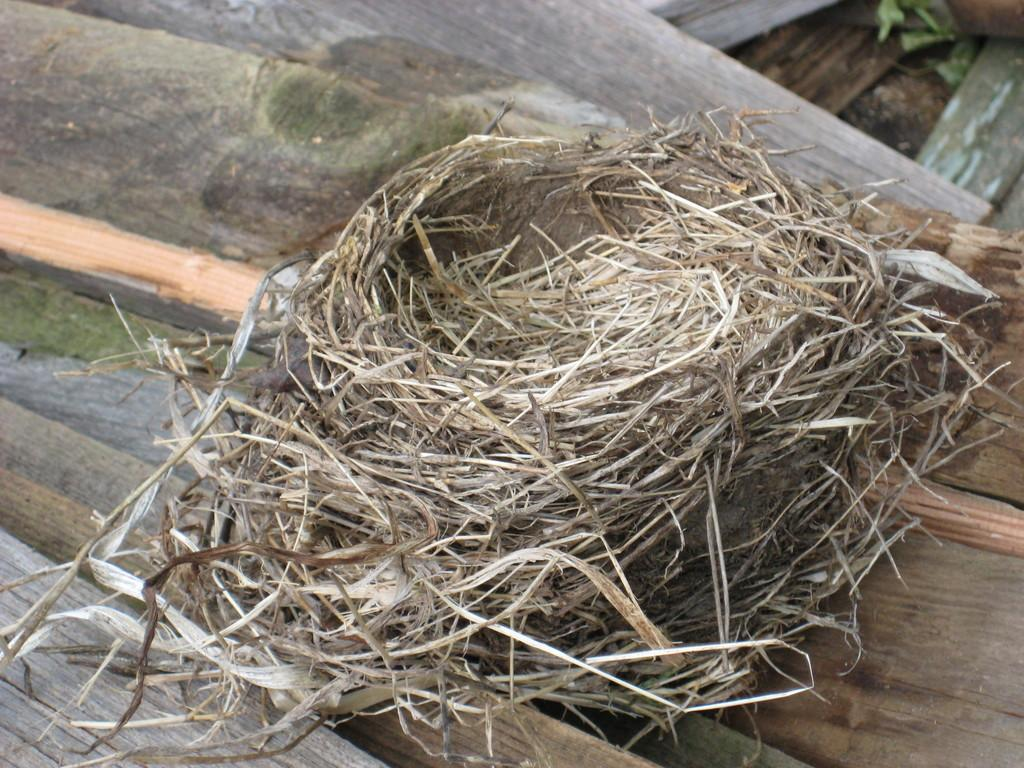What can be found in the image that is used by birds for shelter? There is a nest in the image that is used by birds for shelter. What type of material is present in the image that can be used for construction or other purposes? There are wooden sheets in the image that can be used for construction or other purposes. What type of car can be seen driving through the nest in the image? There is no car present in the image, and the nest is not being driven through. What creature can be seen interacting with the wooden sheets in the image? There is no creature interacting with the wooden sheets in the image. 